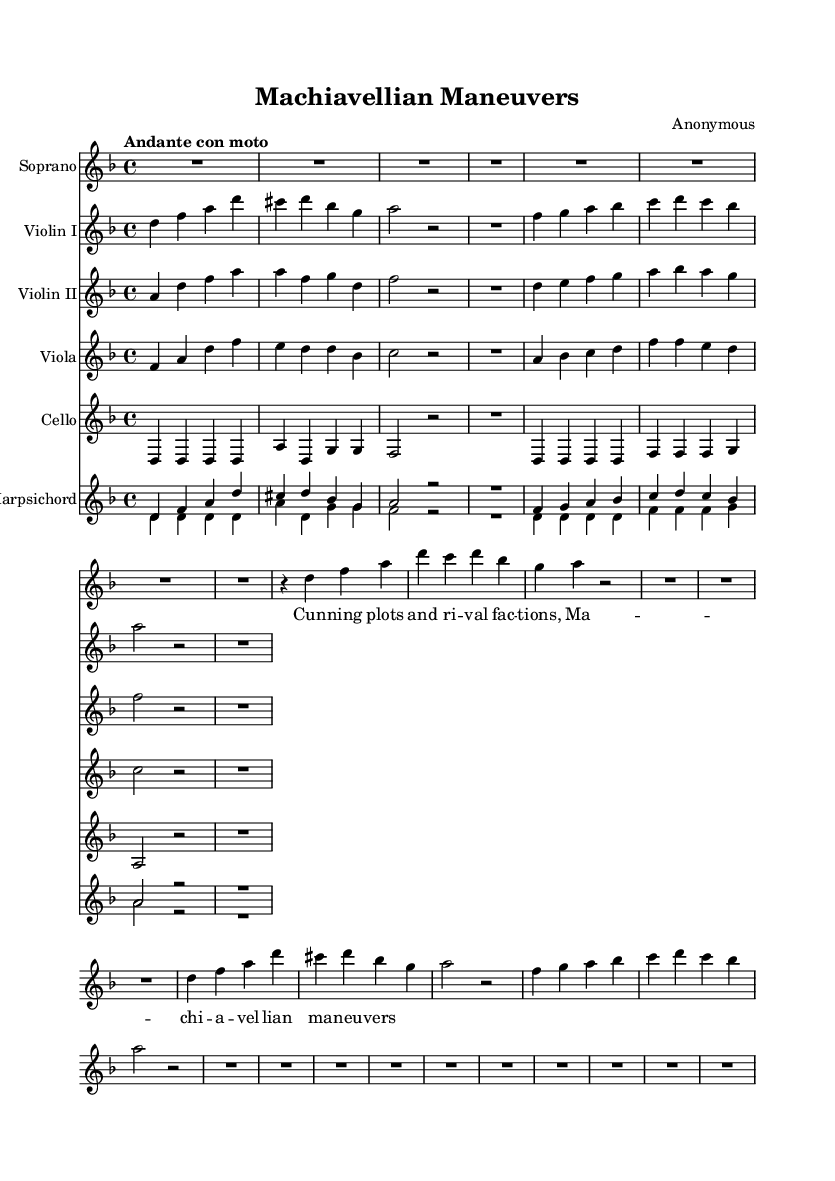What is the key signature of this music? The key signature indicates that there are one flat (B♭), so the key is D minor.
Answer: D minor What is the time signature of this music? The time signature shown in the sheet music is denoted as 4/4, meaning there are four beats in each measure.
Answer: 4/4 What is the tempo marking of this piece? The tempo marking "Andante con moto" suggests a moderately slow tempo, often described as flowing or moving.
Answer: Andante con moto How many sections does this aria have? The sheet music divides the aria into an A section, indicated by repeated phrases, which suggests two main sections.
Answer: 2 What dynamic marking is indicated for the soprano part? The dynamic marking for the soprano is indicated as "up," suggesting that it should be performed with an emphatic or louder tone.
Answer: Up Which instrument is notated at the bottom of the score? The last staff in the score is designated for the Harpsichord, which is a typical instrument used in Baroque music.
Answer: Harpsichord What is the primary theme reflected in the lyrics of the soprano part? The lyrics emphasize cunning plots and Machiavellian strategies, indicating themes of political intrigue.
Answer: Cunning plots 